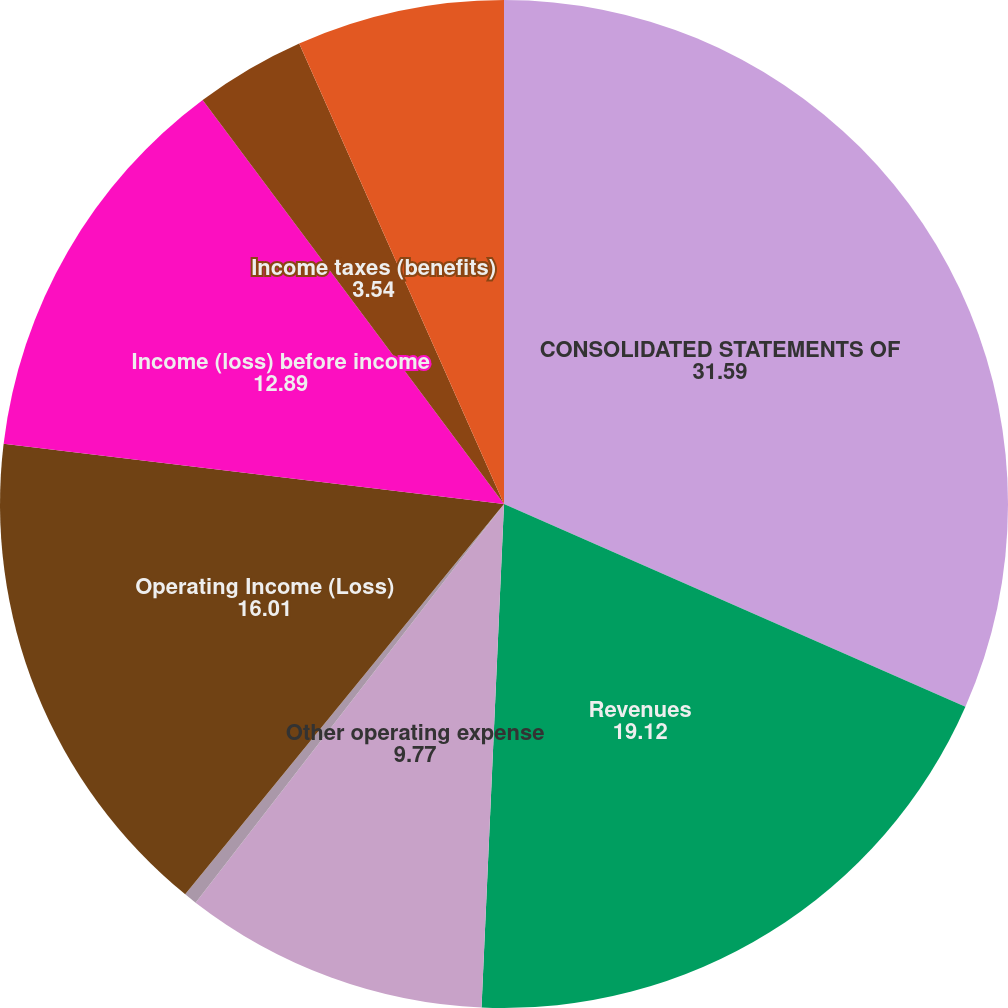Convert chart. <chart><loc_0><loc_0><loc_500><loc_500><pie_chart><fcel>CONSOLIDATED STATEMENTS OF<fcel>Revenues<fcel>Other operating expense<fcel>Provision for depreciation<fcel>Operating Income (Loss)<fcel>Income (loss) before income<fcel>Income taxes (benefits)<fcel>Net Income (Loss)<nl><fcel>31.59%<fcel>19.12%<fcel>9.77%<fcel>0.42%<fcel>16.01%<fcel>12.89%<fcel>3.54%<fcel>6.66%<nl></chart> 